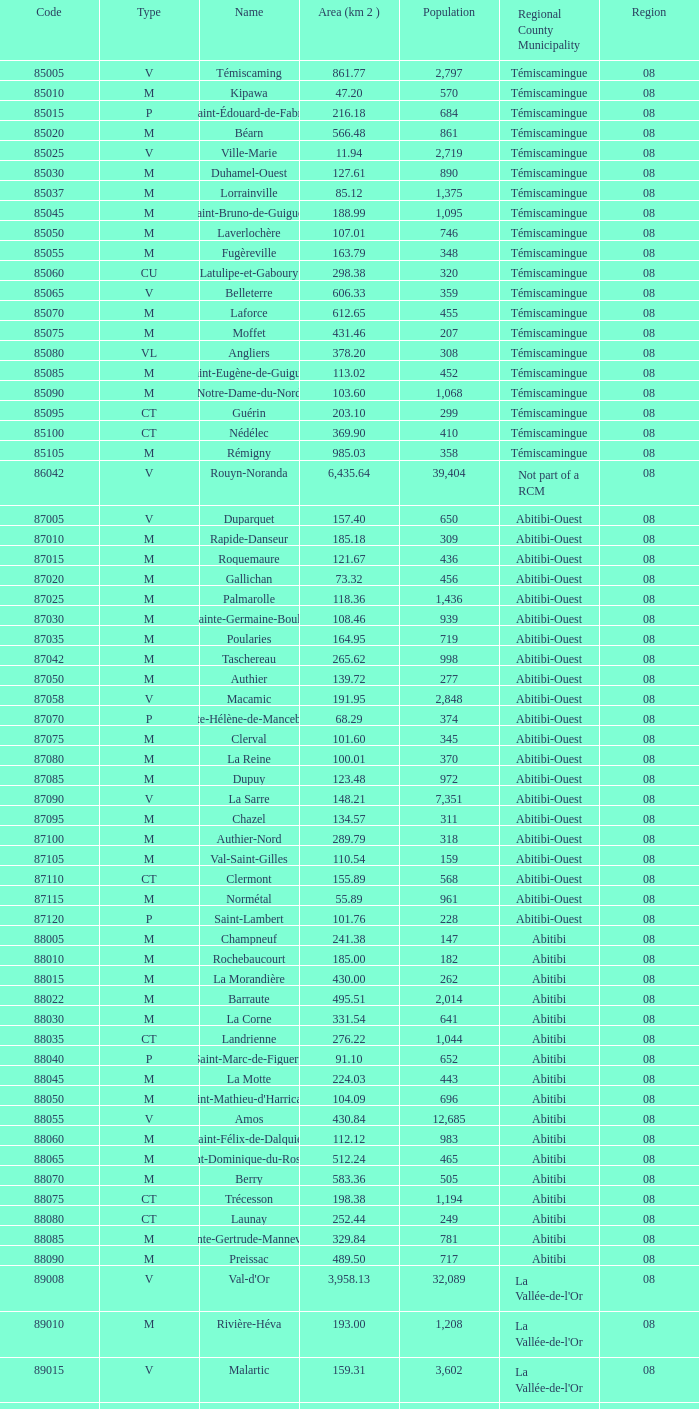46 km2? Abitibi-Ouest. 